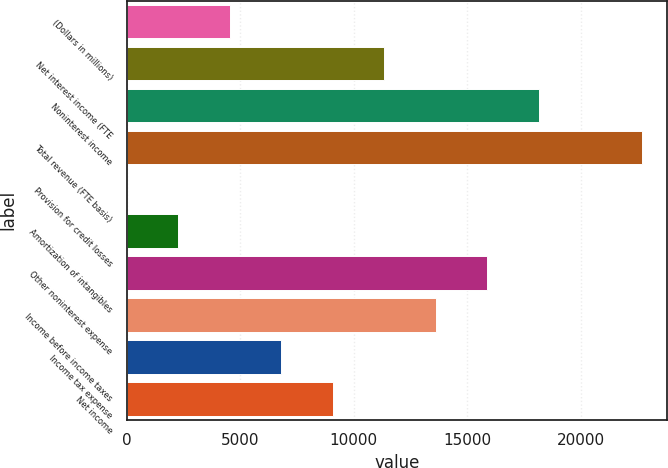Convert chart to OTSL. <chart><loc_0><loc_0><loc_500><loc_500><bar_chart><fcel>(Dollars in millions)<fcel>Net interest income (FTE<fcel>Noninterest income<fcel>Total revenue (FTE basis)<fcel>Provision for credit losses<fcel>Amortization of intangibles<fcel>Other noninterest expense<fcel>Income before income taxes<fcel>Income tax expense<fcel>Net income<nl><fcel>4543<fcel>11348.5<fcel>18154<fcel>22691<fcel>6<fcel>2274.5<fcel>15885.5<fcel>13617<fcel>6811.5<fcel>9080<nl></chart> 